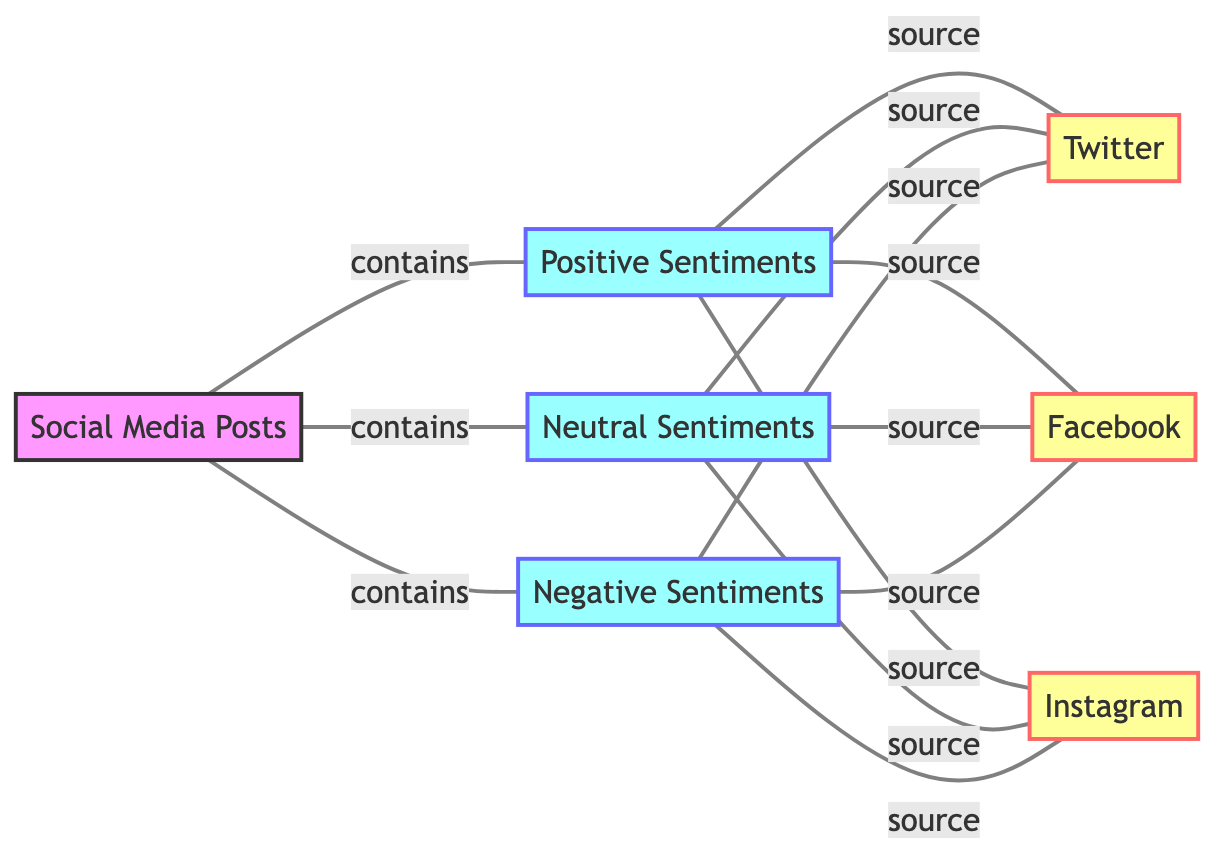What are the three sentiment categories represented in the diagram? The diagram indicates three sentiment categories connected to the "Social Media Posts" node: Positive Sentiments, Neutral Sentiments, and Negative Sentiments.
Answer: Positive Sentiments, Neutral Sentiments, Negative Sentiments How many total nodes are in the diagram? There are seven nodes in the diagram: one for Social Media Posts, three for sentiment categories, and three for social media platforms.
Answer: Seven What type of relationship exists between Social Media Posts and Positive Sentiments? The relationship is labeled as "contains," indicating that Social Media Posts include Positive Sentiments.
Answer: contains How many sources of Positive Sentiments are shown in the diagram? The diagram displays three sources of Positive Sentiments, which are Twitter, Facebook, and Instagram.
Answer: Three Which social media platform is connected to Neutral Sentiments? Neutral Sentiments are connected to Twitter, Facebook, and Instagram, indicating that all three platforms share such sentiments.
Answer: Twitter, Facebook, Instagram What is the relationship between Social Media Posts and Negative Sentiments? The relationship is described as "contains," suggesting that Negative Sentiments are part of the broader category of Social Media Posts.
Answer: contains Which sentiment category has the most connections to social media platforms? All three sentiment categories—Positive, Neutral, and Negative—have an equal number of connections (three each) to the social media platforms. Therefore, they are tied.
Answer: Tied Explain the overall sentiment distribution in the diagram. The diagram showcases three distinct sentiment categories—Positive, Neutral, and Negative—each connected to three social media platforms. This indicates that sentiments are evenly distributed across the platforms for each category.
Answer: Evenly distributed 